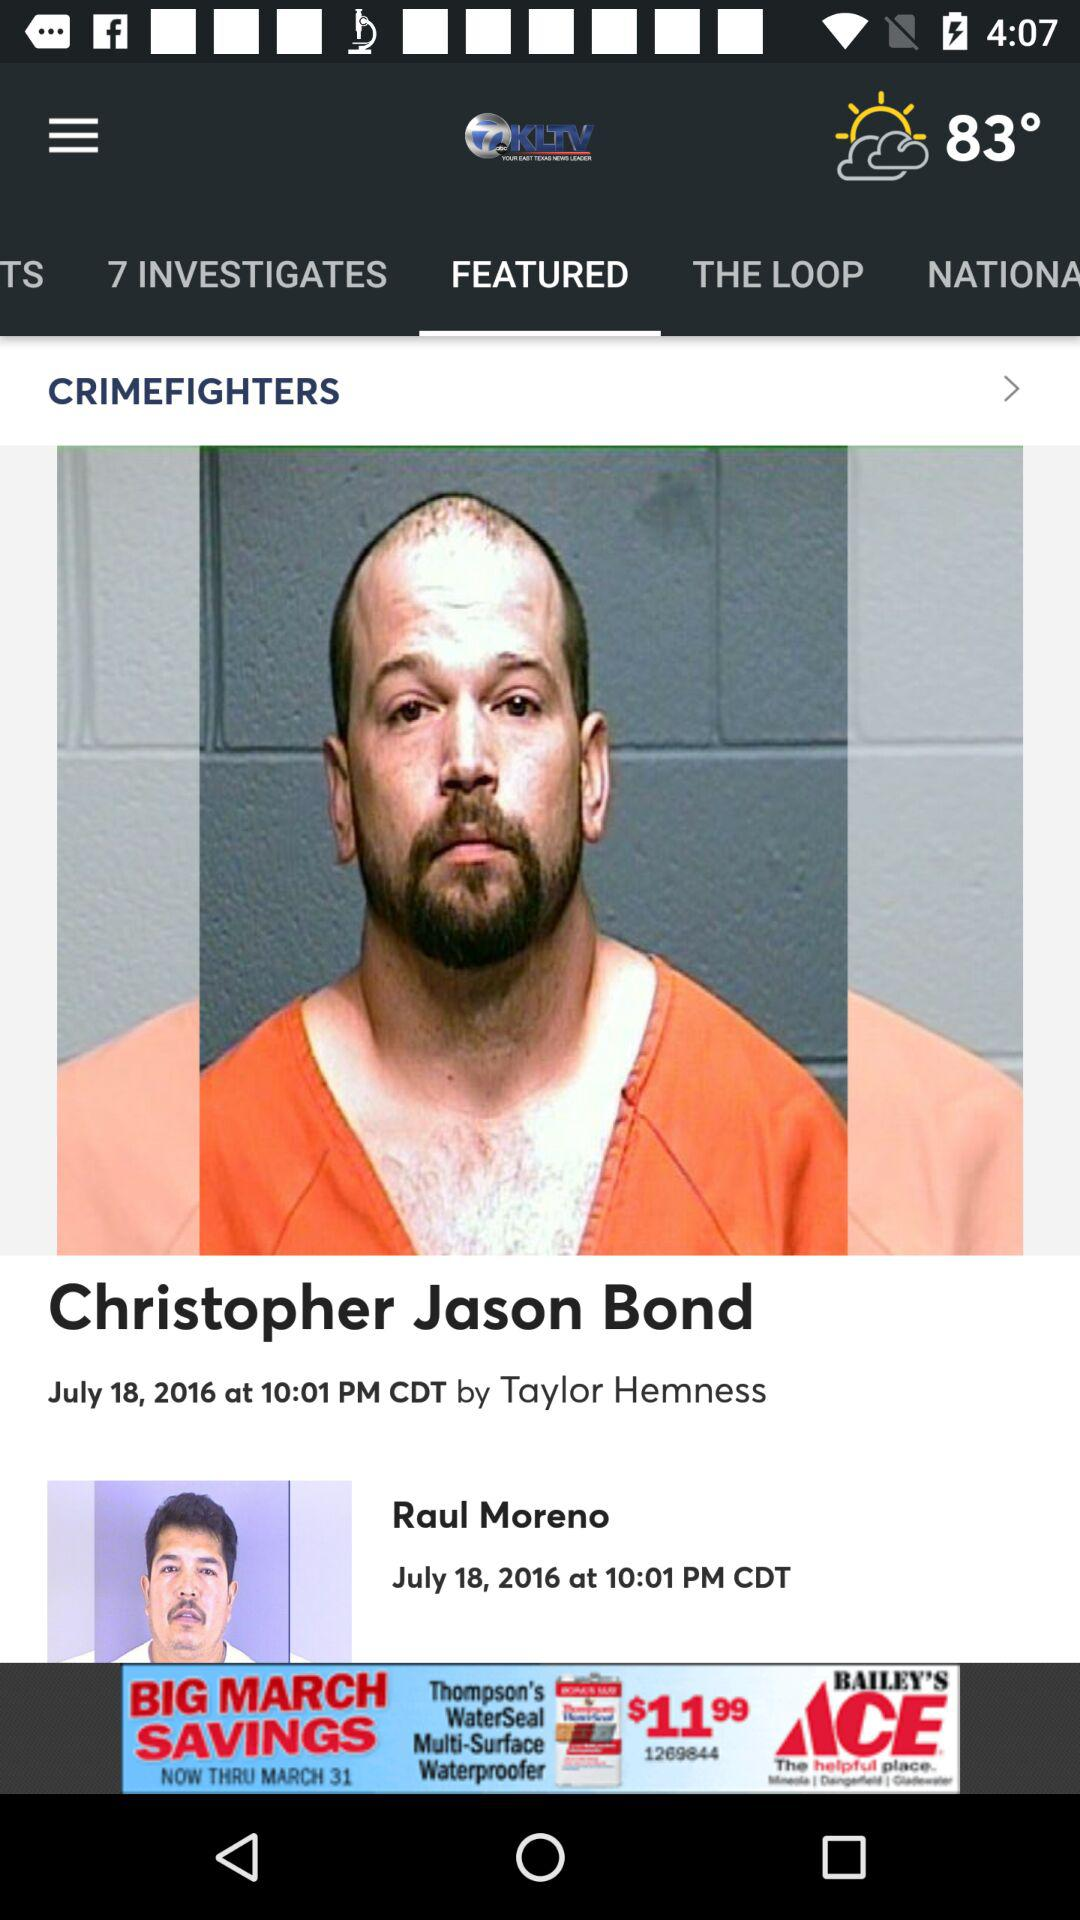What is the name of prisoner?
When the provided information is insufficient, respond with <no answer>. <no answer> 